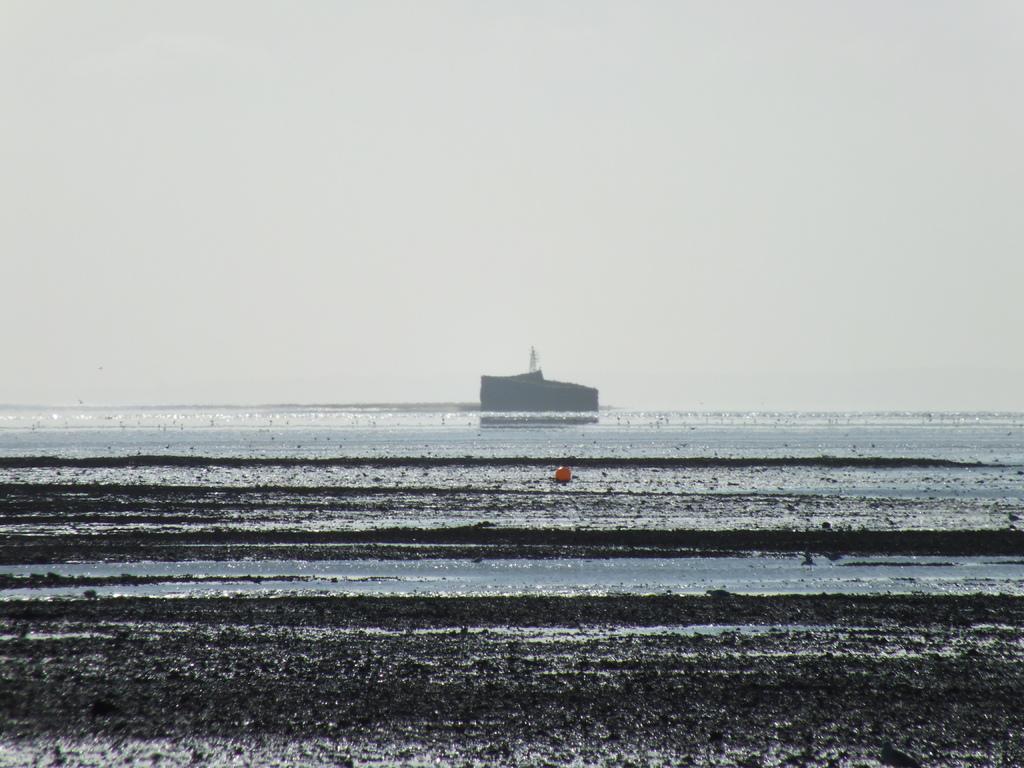Could you give a brief overview of what you see in this image? At the bottom of the image I can see the water. It is looking like an ocean. In the background, I can see a boat and a ship on the water. At the top I can see the sky. 